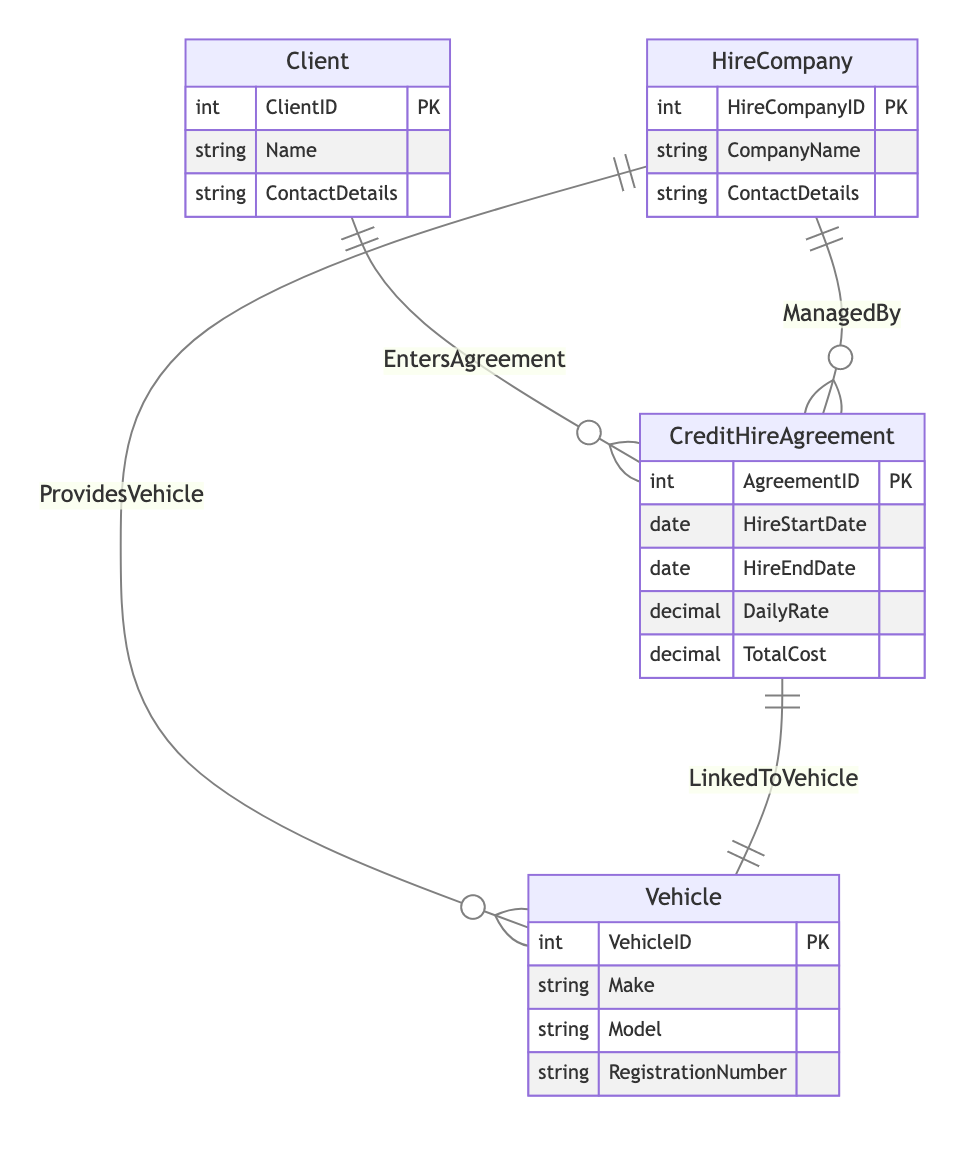What is the primary key of the Client entity? The primary key of the Client entity is ClientID, which uniquely identifies each client in the system.
Answer: ClientID How many entities are present in the diagram? The diagram contains four entities: Client, HireCompany, CreditHireAgreement, and Vehicle, which are represented distinctly within the diagram.
Answer: Four What relationship connects Client and CreditHireAgreement? The relationship that connects Client and CreditHireAgreement is called "EntersAgreement," indicating that clients enter agreements with credit hire.
Answer: EntersAgreement Which entity is linked to the Vehicle entity? The entity linked to the Vehicle entity through the relationship "LinkedToVehicle" is the CreditHireAgreement. This signifies that agreements are associated with specific vehicles.
Answer: CreditHireAgreement How many relationships are there in total? There are four relationships in total: EntersAgreement, ProvidesVehicle, LinkedToVehicle, and ManagedBy, indicating various connections between the entities.
Answer: Four Which entity is a foreign key in the ManagedBy relationship? HireCompanyID from the HireCompany entity acts as a foreign key in the ManagedBy relationship, linking it to the CreditHireAgreement entity.
Answer: HireCompanyID What type of information does the CreditHireAgreement entity store? The CreditHireAgreement entity stores information about hire agreements including details like AgreementID, HireStartDate, HireEndDate, DailyRate, and TotalCost.
Answer: Hire agreement details What is the function of the ProvidesVehicle relationship? The function of the ProvidesVehicle relationship is to indicate that a HireCompany provides a Vehicle, showing a linkage between these two entities.
Answer: To indicate provision of vehicles How is the Client associated with the HireCompany through the diagram? The Client is indirectly associated with the HireCompany through the CreditHireAgreement; the Client enters agreements which are managed by the HireCompany.
Answer: Indirectly through CreditHireAgreement 